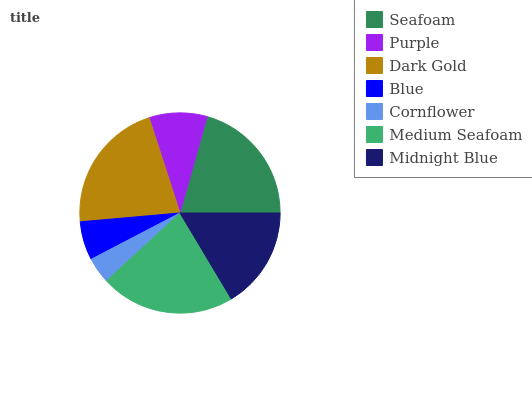Is Cornflower the minimum?
Answer yes or no. Yes. Is Medium Seafoam the maximum?
Answer yes or no. Yes. Is Purple the minimum?
Answer yes or no. No. Is Purple the maximum?
Answer yes or no. No. Is Seafoam greater than Purple?
Answer yes or no. Yes. Is Purple less than Seafoam?
Answer yes or no. Yes. Is Purple greater than Seafoam?
Answer yes or no. No. Is Seafoam less than Purple?
Answer yes or no. No. Is Midnight Blue the high median?
Answer yes or no. Yes. Is Midnight Blue the low median?
Answer yes or no. Yes. Is Medium Seafoam the high median?
Answer yes or no. No. Is Blue the low median?
Answer yes or no. No. 